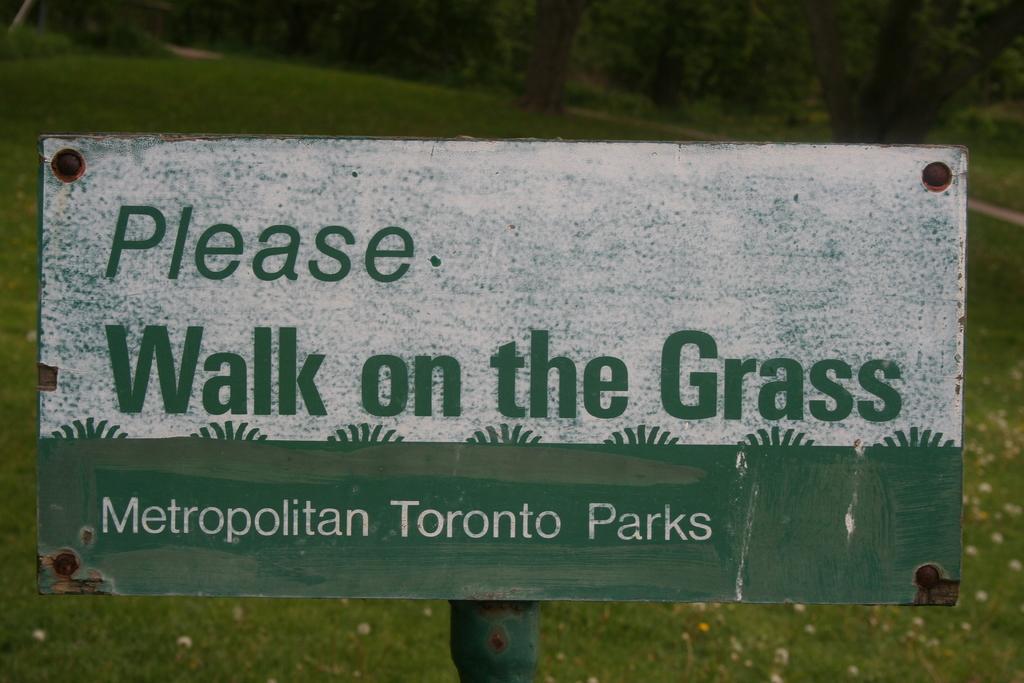Could you give a brief overview of what you see in this image? It is a board about the park. Behind it this is grass. 